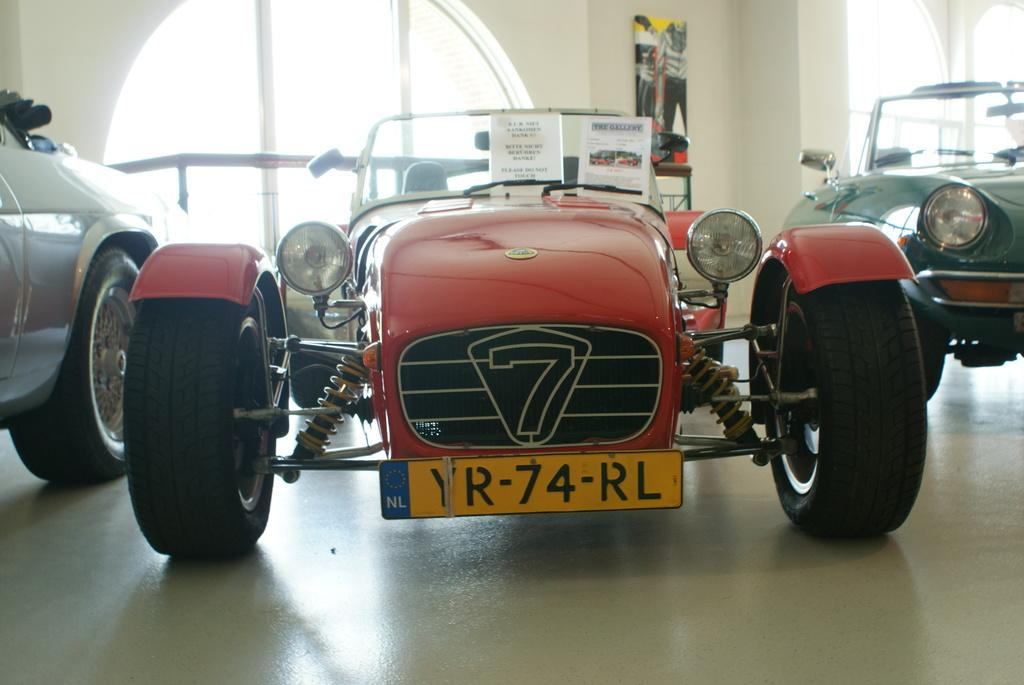What type of vehicles can be seen in the image? There are cars in the image. What is written on the cars? There are placards with text on the cars. What can be seen on the wall in the image? There is a frame on a wall in the image. What is the setting of the image? The setting appears to be a showroom. What type of windows are visible in the image? There are glass windows visible in the image. How many clams are sitting on the hood of the car in the image? There are no clams present in the image; it features cars in a showroom setting. 